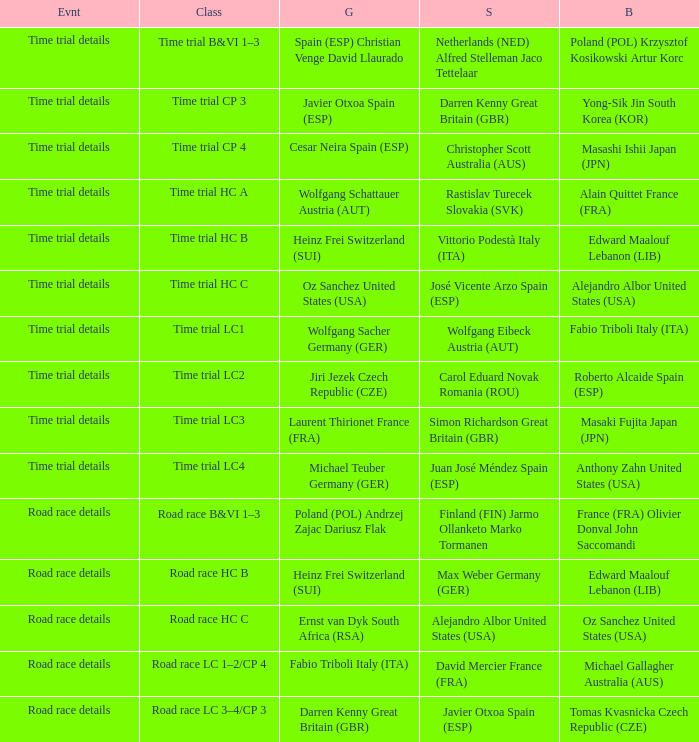Who received gold when the event is road race details and silver is max weber germany (ger)? Heinz Frei Switzerland (SUI). 